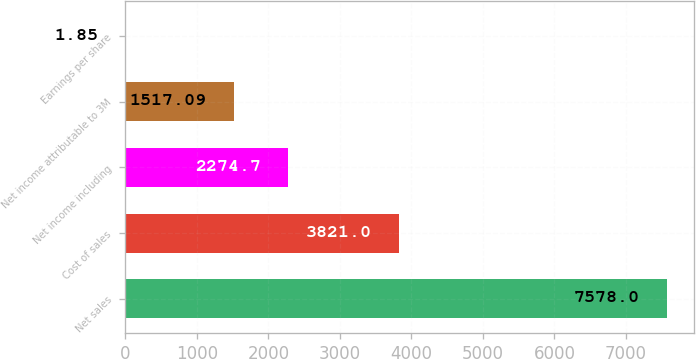<chart> <loc_0><loc_0><loc_500><loc_500><bar_chart><fcel>Net sales<fcel>Cost of sales<fcel>Net income including<fcel>Net income attributable to 3M<fcel>Earnings per share<nl><fcel>7578<fcel>3821<fcel>2274.7<fcel>1517.09<fcel>1.85<nl></chart> 